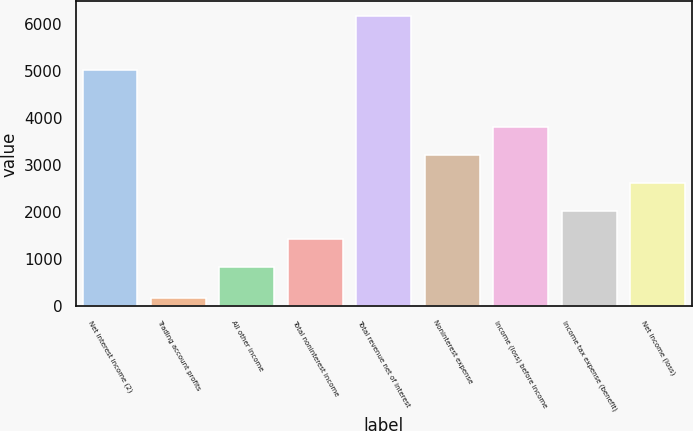Convert chart. <chart><loc_0><loc_0><loc_500><loc_500><bar_chart><fcel>Net interest income (2)<fcel>Trading account profits<fcel>All other income<fcel>Total noninterest income<fcel>Total revenue net of interest<fcel>Noninterest expense<fcel>Income (loss) before income<fcel>Income tax expense (benefit)<fcel>Net income (loss)<nl><fcel>5020<fcel>180<fcel>824<fcel>1423.2<fcel>6172<fcel>3220.8<fcel>3820<fcel>2022.4<fcel>2621.6<nl></chart> 